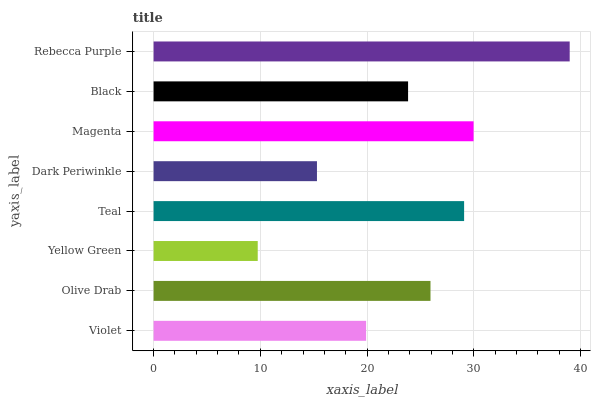Is Yellow Green the minimum?
Answer yes or no. Yes. Is Rebecca Purple the maximum?
Answer yes or no. Yes. Is Olive Drab the minimum?
Answer yes or no. No. Is Olive Drab the maximum?
Answer yes or no. No. Is Olive Drab greater than Violet?
Answer yes or no. Yes. Is Violet less than Olive Drab?
Answer yes or no. Yes. Is Violet greater than Olive Drab?
Answer yes or no. No. Is Olive Drab less than Violet?
Answer yes or no. No. Is Olive Drab the high median?
Answer yes or no. Yes. Is Black the low median?
Answer yes or no. Yes. Is Yellow Green the high median?
Answer yes or no. No. Is Olive Drab the low median?
Answer yes or no. No. 